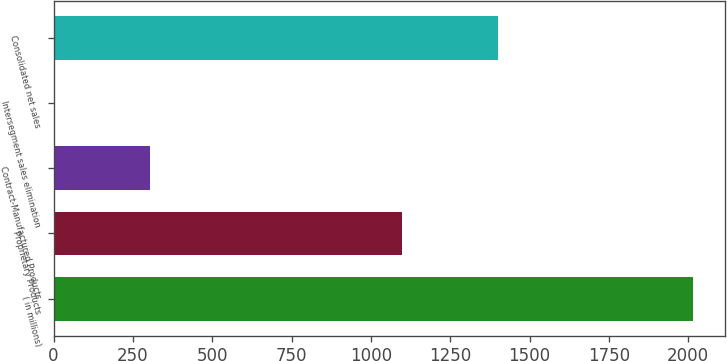Convert chart. <chart><loc_0><loc_0><loc_500><loc_500><bar_chart><fcel>( in millions)<fcel>Proprietary Products<fcel>Contract-Manufactured Products<fcel>Intersegment sales elimination<fcel>Consolidated net sales<nl><fcel>2015<fcel>1098.3<fcel>302.4<fcel>0.9<fcel>1399.8<nl></chart> 